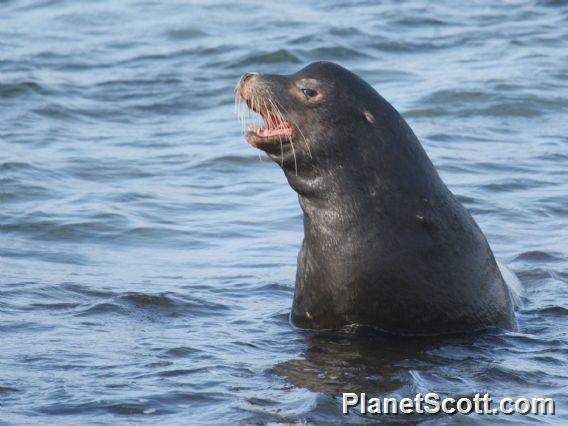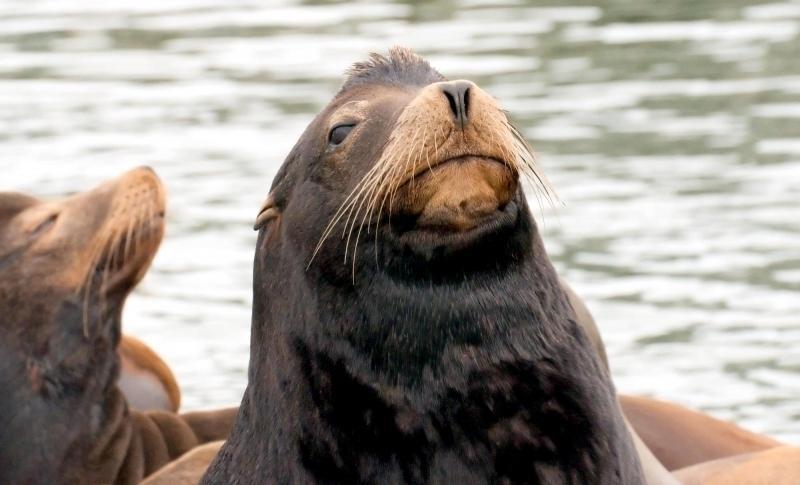The first image is the image on the left, the second image is the image on the right. Evaluate the accuracy of this statement regarding the images: "One of the images contains a bird.". Is it true? Answer yes or no. No. The first image is the image on the left, the second image is the image on the right. Evaluate the accuracy of this statement regarding the images: "There are several sea mammals in the picture on the right.". Is it true? Answer yes or no. Yes. 